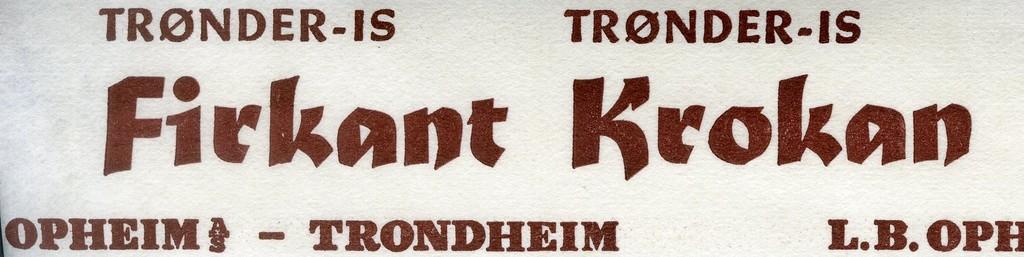What is the title of this sign?
Offer a very short reply. Firkant krokan. 